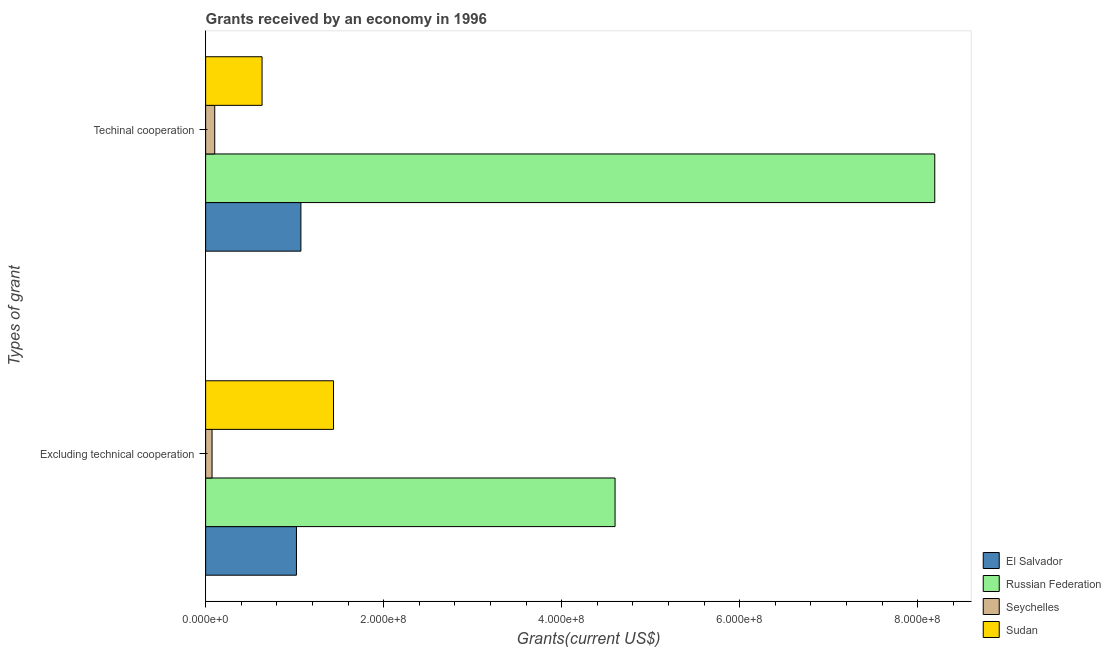What is the label of the 2nd group of bars from the top?
Your answer should be compact. Excluding technical cooperation. What is the amount of grants received(excluding technical cooperation) in El Salvador?
Offer a terse response. 1.02e+08. Across all countries, what is the maximum amount of grants received(excluding technical cooperation)?
Provide a succinct answer. 4.60e+08. Across all countries, what is the minimum amount of grants received(including technical cooperation)?
Provide a short and direct response. 1.02e+07. In which country was the amount of grants received(excluding technical cooperation) maximum?
Make the answer very short. Russian Federation. In which country was the amount of grants received(excluding technical cooperation) minimum?
Offer a terse response. Seychelles. What is the total amount of grants received(excluding technical cooperation) in the graph?
Offer a terse response. 7.13e+08. What is the difference between the amount of grants received(including technical cooperation) in Seychelles and that in Sudan?
Offer a terse response. -5.32e+07. What is the difference between the amount of grants received(excluding technical cooperation) in Russian Federation and the amount of grants received(including technical cooperation) in Seychelles?
Your answer should be compact. 4.50e+08. What is the average amount of grants received(including technical cooperation) per country?
Offer a very short reply. 2.50e+08. What is the difference between the amount of grants received(including technical cooperation) and amount of grants received(excluding technical cooperation) in El Salvador?
Your answer should be compact. 5.00e+06. In how many countries, is the amount of grants received(including technical cooperation) greater than 360000000 US$?
Provide a short and direct response. 1. What is the ratio of the amount of grants received(including technical cooperation) in Sudan to that in El Salvador?
Make the answer very short. 0.59. What does the 2nd bar from the top in Excluding technical cooperation represents?
Give a very brief answer. Seychelles. What does the 3rd bar from the bottom in Techinal cooperation represents?
Provide a short and direct response. Seychelles. How many countries are there in the graph?
Offer a terse response. 4. What is the difference between two consecutive major ticks on the X-axis?
Your response must be concise. 2.00e+08. Are the values on the major ticks of X-axis written in scientific E-notation?
Ensure brevity in your answer.  Yes. Does the graph contain any zero values?
Keep it short and to the point. No. Does the graph contain grids?
Your answer should be very brief. No. How are the legend labels stacked?
Give a very brief answer. Vertical. What is the title of the graph?
Keep it short and to the point. Grants received by an economy in 1996. What is the label or title of the X-axis?
Provide a short and direct response. Grants(current US$). What is the label or title of the Y-axis?
Provide a succinct answer. Types of grant. What is the Grants(current US$) of El Salvador in Excluding technical cooperation?
Your answer should be compact. 1.02e+08. What is the Grants(current US$) of Russian Federation in Excluding technical cooperation?
Your answer should be very brief. 4.60e+08. What is the Grants(current US$) of Seychelles in Excluding technical cooperation?
Your answer should be compact. 7.21e+06. What is the Grants(current US$) of Sudan in Excluding technical cooperation?
Your response must be concise. 1.44e+08. What is the Grants(current US$) in El Salvador in Techinal cooperation?
Keep it short and to the point. 1.07e+08. What is the Grants(current US$) in Russian Federation in Techinal cooperation?
Ensure brevity in your answer.  8.19e+08. What is the Grants(current US$) of Seychelles in Techinal cooperation?
Your response must be concise. 1.02e+07. What is the Grants(current US$) of Sudan in Techinal cooperation?
Offer a very short reply. 6.34e+07. Across all Types of grant, what is the maximum Grants(current US$) in El Salvador?
Your answer should be compact. 1.07e+08. Across all Types of grant, what is the maximum Grants(current US$) of Russian Federation?
Your answer should be compact. 8.19e+08. Across all Types of grant, what is the maximum Grants(current US$) of Seychelles?
Offer a very short reply. 1.02e+07. Across all Types of grant, what is the maximum Grants(current US$) in Sudan?
Give a very brief answer. 1.44e+08. Across all Types of grant, what is the minimum Grants(current US$) of El Salvador?
Ensure brevity in your answer.  1.02e+08. Across all Types of grant, what is the minimum Grants(current US$) of Russian Federation?
Provide a succinct answer. 4.60e+08. Across all Types of grant, what is the minimum Grants(current US$) of Seychelles?
Ensure brevity in your answer.  7.21e+06. Across all Types of grant, what is the minimum Grants(current US$) of Sudan?
Your answer should be very brief. 6.34e+07. What is the total Grants(current US$) of El Salvador in the graph?
Offer a very short reply. 2.09e+08. What is the total Grants(current US$) in Russian Federation in the graph?
Offer a very short reply. 1.28e+09. What is the total Grants(current US$) in Seychelles in the graph?
Ensure brevity in your answer.  1.74e+07. What is the total Grants(current US$) in Sudan in the graph?
Provide a succinct answer. 2.07e+08. What is the difference between the Grants(current US$) in El Salvador in Excluding technical cooperation and that in Techinal cooperation?
Ensure brevity in your answer.  -5.00e+06. What is the difference between the Grants(current US$) of Russian Federation in Excluding technical cooperation and that in Techinal cooperation?
Your response must be concise. -3.59e+08. What is the difference between the Grants(current US$) of Seychelles in Excluding technical cooperation and that in Techinal cooperation?
Your answer should be very brief. -3.02e+06. What is the difference between the Grants(current US$) in Sudan in Excluding technical cooperation and that in Techinal cooperation?
Keep it short and to the point. 8.02e+07. What is the difference between the Grants(current US$) in El Salvador in Excluding technical cooperation and the Grants(current US$) in Russian Federation in Techinal cooperation?
Give a very brief answer. -7.17e+08. What is the difference between the Grants(current US$) of El Salvador in Excluding technical cooperation and the Grants(current US$) of Seychelles in Techinal cooperation?
Make the answer very short. 9.18e+07. What is the difference between the Grants(current US$) of El Salvador in Excluding technical cooperation and the Grants(current US$) of Sudan in Techinal cooperation?
Offer a terse response. 3.86e+07. What is the difference between the Grants(current US$) in Russian Federation in Excluding technical cooperation and the Grants(current US$) in Seychelles in Techinal cooperation?
Provide a short and direct response. 4.50e+08. What is the difference between the Grants(current US$) in Russian Federation in Excluding technical cooperation and the Grants(current US$) in Sudan in Techinal cooperation?
Keep it short and to the point. 3.97e+08. What is the difference between the Grants(current US$) in Seychelles in Excluding technical cooperation and the Grants(current US$) in Sudan in Techinal cooperation?
Your answer should be compact. -5.62e+07. What is the average Grants(current US$) in El Salvador per Types of grant?
Your response must be concise. 1.05e+08. What is the average Grants(current US$) in Russian Federation per Types of grant?
Your answer should be very brief. 6.40e+08. What is the average Grants(current US$) of Seychelles per Types of grant?
Provide a succinct answer. 8.72e+06. What is the average Grants(current US$) in Sudan per Types of grant?
Make the answer very short. 1.04e+08. What is the difference between the Grants(current US$) in El Salvador and Grants(current US$) in Russian Federation in Excluding technical cooperation?
Your answer should be compact. -3.58e+08. What is the difference between the Grants(current US$) of El Salvador and Grants(current US$) of Seychelles in Excluding technical cooperation?
Your answer should be compact. 9.48e+07. What is the difference between the Grants(current US$) of El Salvador and Grants(current US$) of Sudan in Excluding technical cooperation?
Your answer should be compact. -4.16e+07. What is the difference between the Grants(current US$) of Russian Federation and Grants(current US$) of Seychelles in Excluding technical cooperation?
Offer a very short reply. 4.53e+08. What is the difference between the Grants(current US$) of Russian Federation and Grants(current US$) of Sudan in Excluding technical cooperation?
Keep it short and to the point. 3.16e+08. What is the difference between the Grants(current US$) in Seychelles and Grants(current US$) in Sudan in Excluding technical cooperation?
Your response must be concise. -1.36e+08. What is the difference between the Grants(current US$) of El Salvador and Grants(current US$) of Russian Federation in Techinal cooperation?
Your response must be concise. -7.12e+08. What is the difference between the Grants(current US$) of El Salvador and Grants(current US$) of Seychelles in Techinal cooperation?
Provide a short and direct response. 9.68e+07. What is the difference between the Grants(current US$) in El Salvador and Grants(current US$) in Sudan in Techinal cooperation?
Your response must be concise. 4.36e+07. What is the difference between the Grants(current US$) in Russian Federation and Grants(current US$) in Seychelles in Techinal cooperation?
Offer a terse response. 8.09e+08. What is the difference between the Grants(current US$) of Russian Federation and Grants(current US$) of Sudan in Techinal cooperation?
Provide a short and direct response. 7.56e+08. What is the difference between the Grants(current US$) in Seychelles and Grants(current US$) in Sudan in Techinal cooperation?
Your answer should be compact. -5.32e+07. What is the ratio of the Grants(current US$) of El Salvador in Excluding technical cooperation to that in Techinal cooperation?
Ensure brevity in your answer.  0.95. What is the ratio of the Grants(current US$) in Russian Federation in Excluding technical cooperation to that in Techinal cooperation?
Make the answer very short. 0.56. What is the ratio of the Grants(current US$) of Seychelles in Excluding technical cooperation to that in Techinal cooperation?
Offer a very short reply. 0.7. What is the ratio of the Grants(current US$) in Sudan in Excluding technical cooperation to that in Techinal cooperation?
Offer a very short reply. 2.27. What is the difference between the highest and the second highest Grants(current US$) of Russian Federation?
Give a very brief answer. 3.59e+08. What is the difference between the highest and the second highest Grants(current US$) in Seychelles?
Your answer should be very brief. 3.02e+06. What is the difference between the highest and the second highest Grants(current US$) of Sudan?
Make the answer very short. 8.02e+07. What is the difference between the highest and the lowest Grants(current US$) of El Salvador?
Offer a very short reply. 5.00e+06. What is the difference between the highest and the lowest Grants(current US$) in Russian Federation?
Provide a short and direct response. 3.59e+08. What is the difference between the highest and the lowest Grants(current US$) of Seychelles?
Your answer should be compact. 3.02e+06. What is the difference between the highest and the lowest Grants(current US$) in Sudan?
Ensure brevity in your answer.  8.02e+07. 